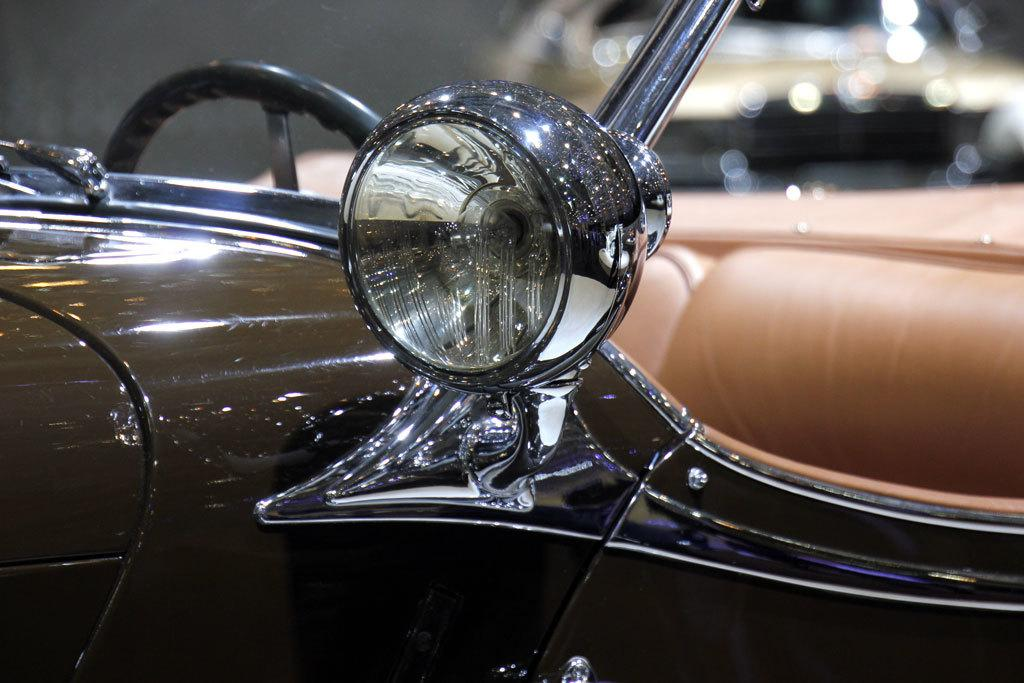What is the main subject of the image? There is a car in the center of the image. Can you describe the car in the image? The provided facts do not give any details about the car's appearance or features. Is there anything else visible in the image besides the car? The provided facts do not mention any other objects or subjects in the image. What type of fruit is hanging from the car in the image? There is no fruit present in the image, as it only features a car in the center. 